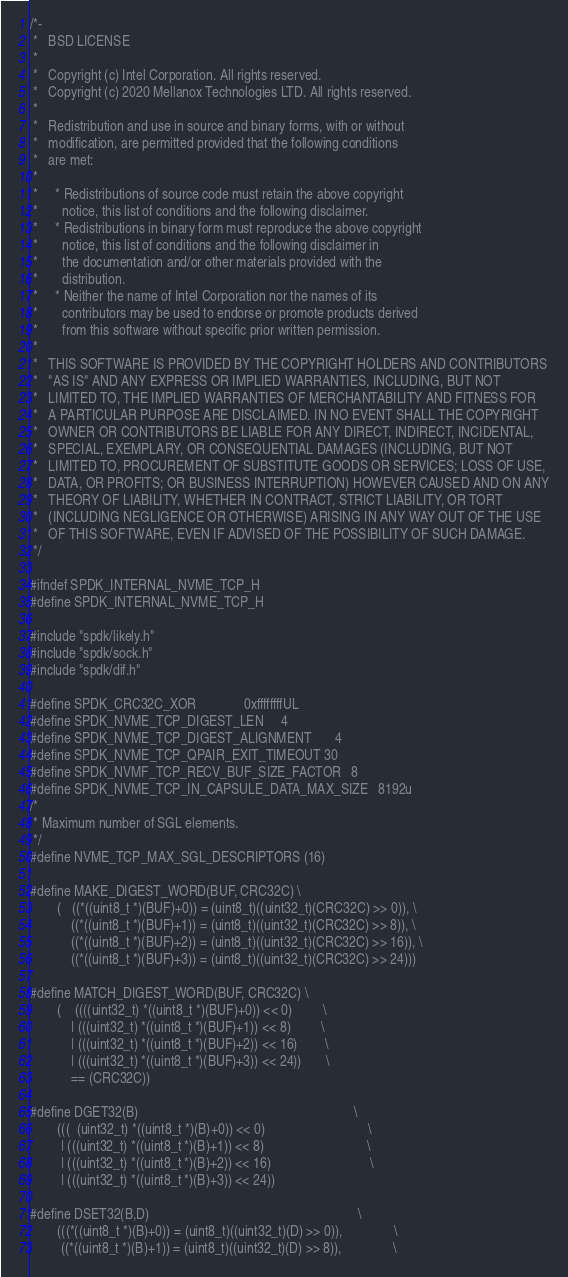<code> <loc_0><loc_0><loc_500><loc_500><_C_>/*-
 *   BSD LICENSE
 *
 *   Copyright (c) Intel Corporation. All rights reserved.
 *   Copyright (c) 2020 Mellanox Technologies LTD. All rights reserved.
 *
 *   Redistribution and use in source and binary forms, with or without
 *   modification, are permitted provided that the following conditions
 *   are met:
 *
 *     * Redistributions of source code must retain the above copyright
 *       notice, this list of conditions and the following disclaimer.
 *     * Redistributions in binary form must reproduce the above copyright
 *       notice, this list of conditions and the following disclaimer in
 *       the documentation and/or other materials provided with the
 *       distribution.
 *     * Neither the name of Intel Corporation nor the names of its
 *       contributors may be used to endorse or promote products derived
 *       from this software without specific prior written permission.
 *
 *   THIS SOFTWARE IS PROVIDED BY THE COPYRIGHT HOLDERS AND CONTRIBUTORS
 *   "AS IS" AND ANY EXPRESS OR IMPLIED WARRANTIES, INCLUDING, BUT NOT
 *   LIMITED TO, THE IMPLIED WARRANTIES OF MERCHANTABILITY AND FITNESS FOR
 *   A PARTICULAR PURPOSE ARE DISCLAIMED. IN NO EVENT SHALL THE COPYRIGHT
 *   OWNER OR CONTRIBUTORS BE LIABLE FOR ANY DIRECT, INDIRECT, INCIDENTAL,
 *   SPECIAL, EXEMPLARY, OR CONSEQUENTIAL DAMAGES (INCLUDING, BUT NOT
 *   LIMITED TO, PROCUREMENT OF SUBSTITUTE GOODS OR SERVICES; LOSS OF USE,
 *   DATA, OR PROFITS; OR BUSINESS INTERRUPTION) HOWEVER CAUSED AND ON ANY
 *   THEORY OF LIABILITY, WHETHER IN CONTRACT, STRICT LIABILITY, OR TORT
 *   (INCLUDING NEGLIGENCE OR OTHERWISE) ARISING IN ANY WAY OUT OF THE USE
 *   OF THIS SOFTWARE, EVEN IF ADVISED OF THE POSSIBILITY OF SUCH DAMAGE.
 */

#ifndef SPDK_INTERNAL_NVME_TCP_H
#define SPDK_INTERNAL_NVME_TCP_H

#include "spdk/likely.h"
#include "spdk/sock.h"
#include "spdk/dif.h"

#define SPDK_CRC32C_XOR				0xffffffffUL
#define SPDK_NVME_TCP_DIGEST_LEN		4
#define SPDK_NVME_TCP_DIGEST_ALIGNMENT		4
#define SPDK_NVME_TCP_QPAIR_EXIT_TIMEOUT	30
#define SPDK_NVMF_TCP_RECV_BUF_SIZE_FACTOR	8
#define SPDK_NVME_TCP_IN_CAPSULE_DATA_MAX_SIZE	8192u
/*
 * Maximum number of SGL elements.
 */
#define NVME_TCP_MAX_SGL_DESCRIPTORS	(16)

#define MAKE_DIGEST_WORD(BUF, CRC32C) \
        (   ((*((uint8_t *)(BUF)+0)) = (uint8_t)((uint32_t)(CRC32C) >> 0)), \
            ((*((uint8_t *)(BUF)+1)) = (uint8_t)((uint32_t)(CRC32C) >> 8)), \
            ((*((uint8_t *)(BUF)+2)) = (uint8_t)((uint32_t)(CRC32C) >> 16)), \
            ((*((uint8_t *)(BUF)+3)) = (uint8_t)((uint32_t)(CRC32C) >> 24)))

#define MATCH_DIGEST_WORD(BUF, CRC32C) \
        (    ((((uint32_t) *((uint8_t *)(BUF)+0)) << 0)         \
            | (((uint32_t) *((uint8_t *)(BUF)+1)) << 8)         \
            | (((uint32_t) *((uint8_t *)(BUF)+2)) << 16)        \
            | (((uint32_t) *((uint8_t *)(BUF)+3)) << 24))       \
            == (CRC32C))

#define DGET32(B)                                                               \
        (((  (uint32_t) *((uint8_t *)(B)+0)) << 0)                              \
         | (((uint32_t) *((uint8_t *)(B)+1)) << 8)                              \
         | (((uint32_t) *((uint8_t *)(B)+2)) << 16)                             \
         | (((uint32_t) *((uint8_t *)(B)+3)) << 24))

#define DSET32(B,D)                                                             \
        (((*((uint8_t *)(B)+0)) = (uint8_t)((uint32_t)(D) >> 0)),               \
         ((*((uint8_t *)(B)+1)) = (uint8_t)((uint32_t)(D) >> 8)),               \</code> 